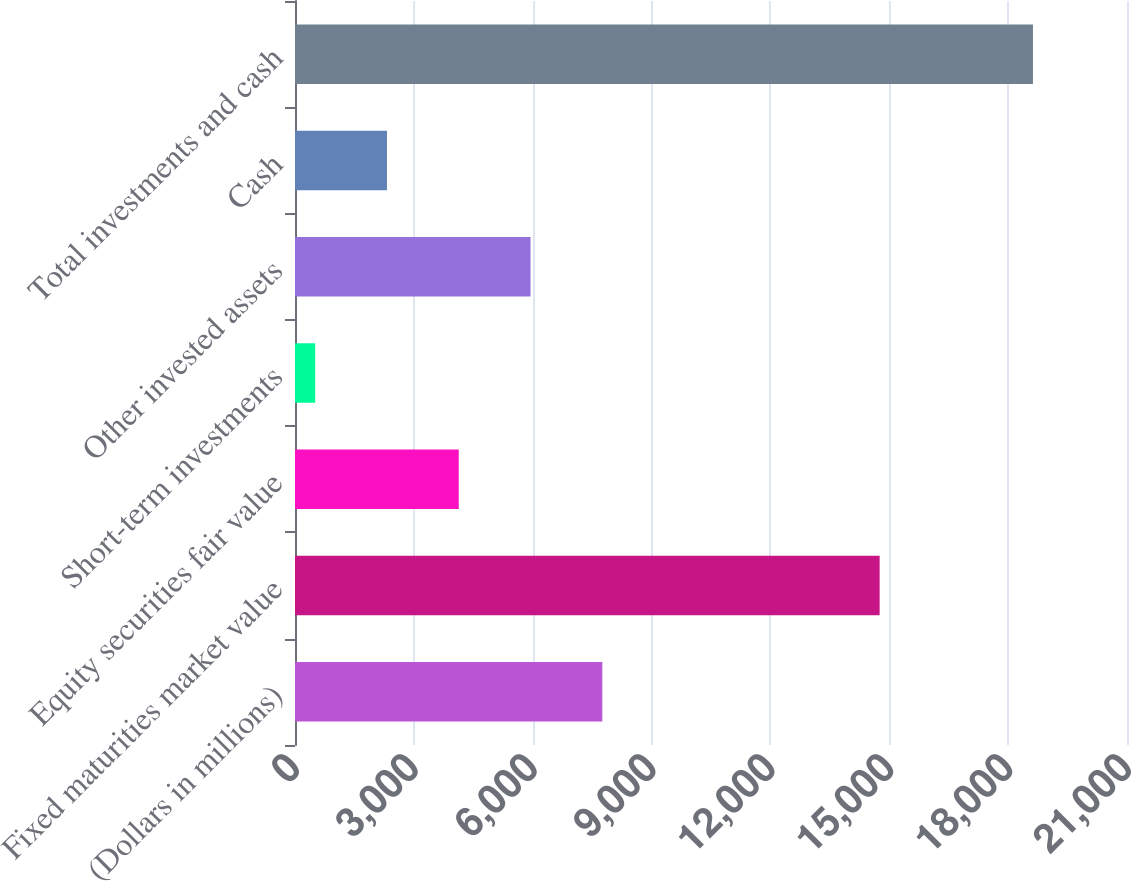Convert chart. <chart><loc_0><loc_0><loc_500><loc_500><bar_chart><fcel>(Dollars in millions)<fcel>Fixed maturities market value<fcel>Equity securities fair value<fcel>Short-term investments<fcel>Other invested assets<fcel>Cash<fcel>Total investments and cash<nl><fcel>7756.42<fcel>14756.8<fcel>4133.06<fcel>509.7<fcel>5944.74<fcel>2321.38<fcel>18626.5<nl></chart> 